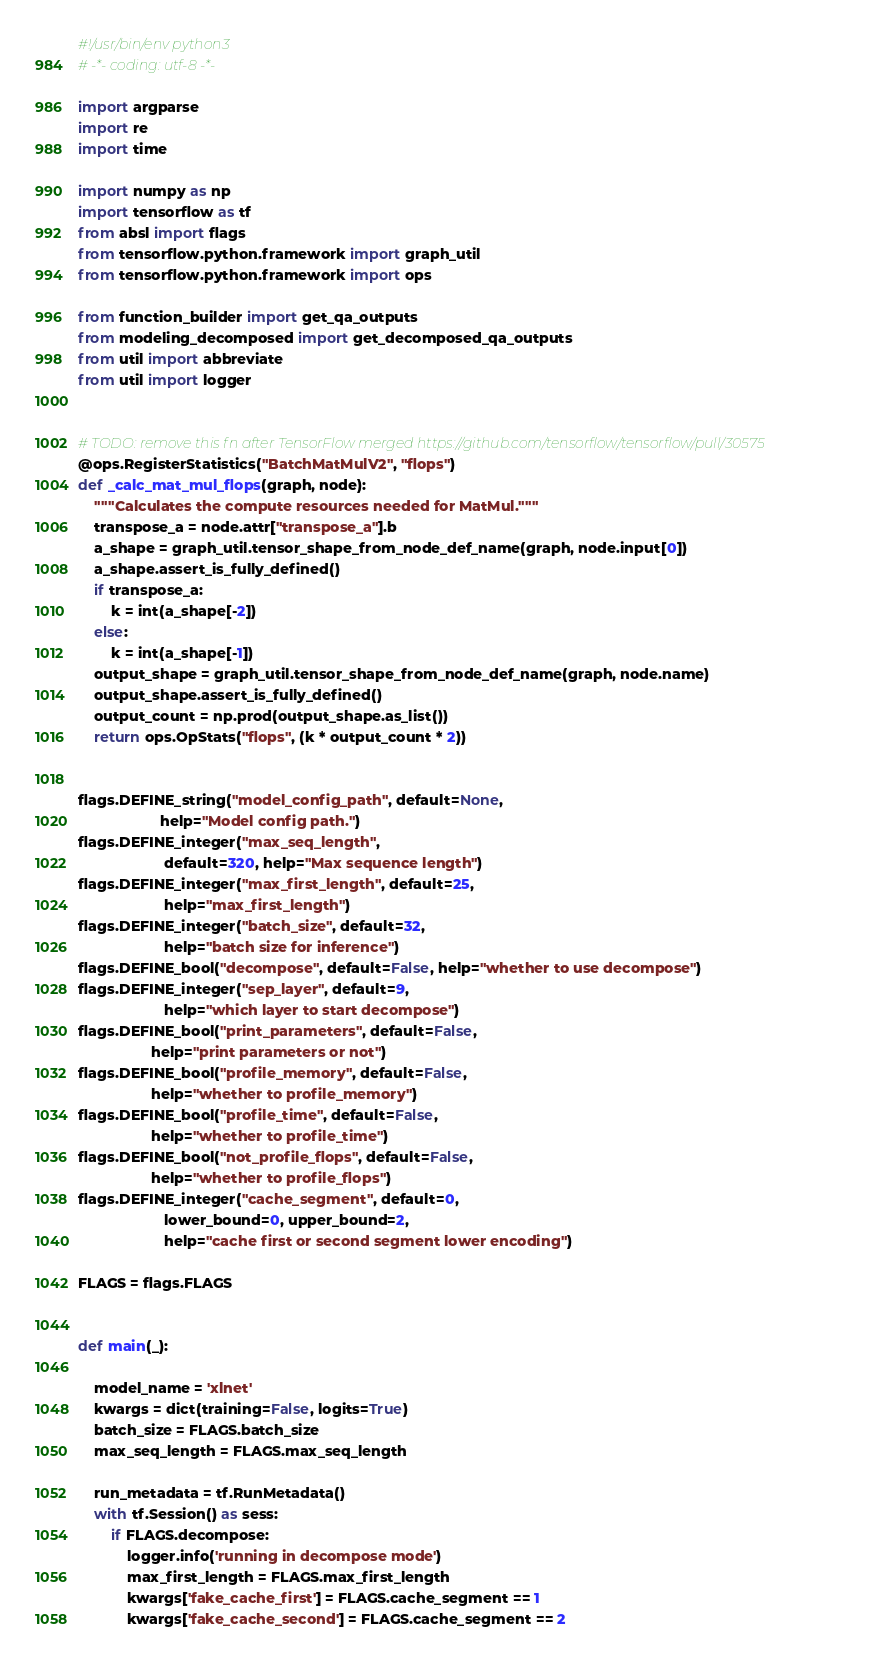<code> <loc_0><loc_0><loc_500><loc_500><_Python_>#!/usr/bin/env python3
# -*- coding: utf-8 -*-

import argparse
import re
import time

import numpy as np
import tensorflow as tf
from absl import flags
from tensorflow.python.framework import graph_util
from tensorflow.python.framework import ops

from function_builder import get_qa_outputs
from modeling_decomposed import get_decomposed_qa_outputs
from util import abbreviate
from util import logger


# TODO: remove this fn after TensorFlow merged https://github.com/tensorflow/tensorflow/pull/30575
@ops.RegisterStatistics("BatchMatMulV2", "flops")
def _calc_mat_mul_flops(graph, node):
    """Calculates the compute resources needed for MatMul."""
    transpose_a = node.attr["transpose_a"].b
    a_shape = graph_util.tensor_shape_from_node_def_name(graph, node.input[0])
    a_shape.assert_is_fully_defined()
    if transpose_a:
        k = int(a_shape[-2])
    else:
        k = int(a_shape[-1])
    output_shape = graph_util.tensor_shape_from_node_def_name(graph, node.name)
    output_shape.assert_is_fully_defined()
    output_count = np.prod(output_shape.as_list())
    return ops.OpStats("flops", (k * output_count * 2))


flags.DEFINE_string("model_config_path", default=None,
                    help="Model config path.")
flags.DEFINE_integer("max_seq_length",
                     default=320, help="Max sequence length")
flags.DEFINE_integer("max_first_length", default=25,
                     help="max_first_length")
flags.DEFINE_integer("batch_size", default=32,
                     help="batch size for inference")
flags.DEFINE_bool("decompose", default=False, help="whether to use decompose")
flags.DEFINE_integer("sep_layer", default=9,
                     help="which layer to start decompose")
flags.DEFINE_bool("print_parameters", default=False,
                  help="print parameters or not")
flags.DEFINE_bool("profile_memory", default=False,
                  help="whether to profile_memory")
flags.DEFINE_bool("profile_time", default=False,
                  help="whether to profile_time")
flags.DEFINE_bool("not_profile_flops", default=False,
                  help="whether to profile_flops")
flags.DEFINE_integer("cache_segment", default=0,
                     lower_bound=0, upper_bound=2,
                     help="cache first or second segment lower encoding")

FLAGS = flags.FLAGS


def main(_):

    model_name = 'xlnet'
    kwargs = dict(training=False, logits=True)
    batch_size = FLAGS.batch_size
    max_seq_length = FLAGS.max_seq_length

    run_metadata = tf.RunMetadata()
    with tf.Session() as sess:
        if FLAGS.decompose:
            logger.info('running in decompose mode')
            max_first_length = FLAGS.max_first_length
            kwargs['fake_cache_first'] = FLAGS.cache_segment == 1
            kwargs['fake_cache_second'] = FLAGS.cache_segment == 2</code> 